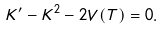Convert formula to latex. <formula><loc_0><loc_0><loc_500><loc_500>K ^ { \prime } - K ^ { 2 } - 2 V ( T ) = 0 .</formula> 